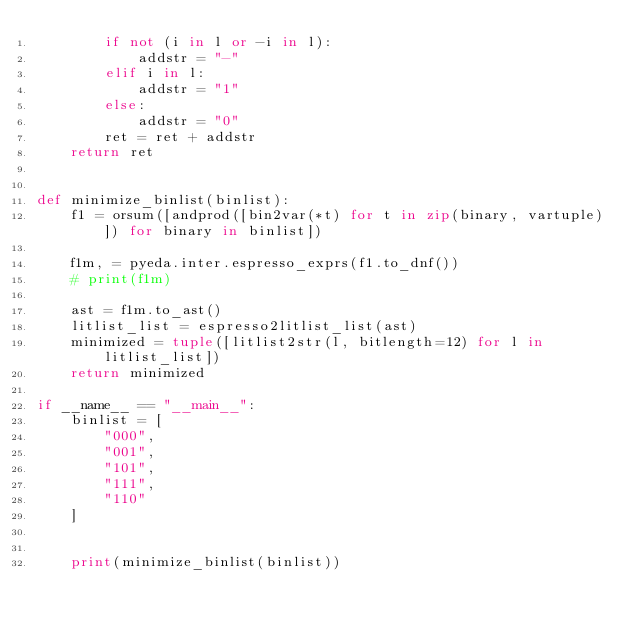Convert code to text. <code><loc_0><loc_0><loc_500><loc_500><_Python_>        if not (i in l or -i in l):
            addstr = "-"
        elif i in l:
            addstr = "1"
        else:
            addstr = "0"
        ret = ret + addstr
    return ret


def minimize_binlist(binlist):
    f1 = orsum([andprod([bin2var(*t) for t in zip(binary, vartuple)]) for binary in binlist])

    f1m, = pyeda.inter.espresso_exprs(f1.to_dnf())
    # print(f1m)

    ast = f1m.to_ast()
    litlist_list = espresso2litlist_list(ast)
    minimized = tuple([litlist2str(l, bitlength=12) for l in litlist_list])
    return minimized

if __name__ == "__main__":
    binlist = [
        "000",
        "001",
        "101",
        "111",
        "110"
    ]


    print(minimize_binlist(binlist))</code> 